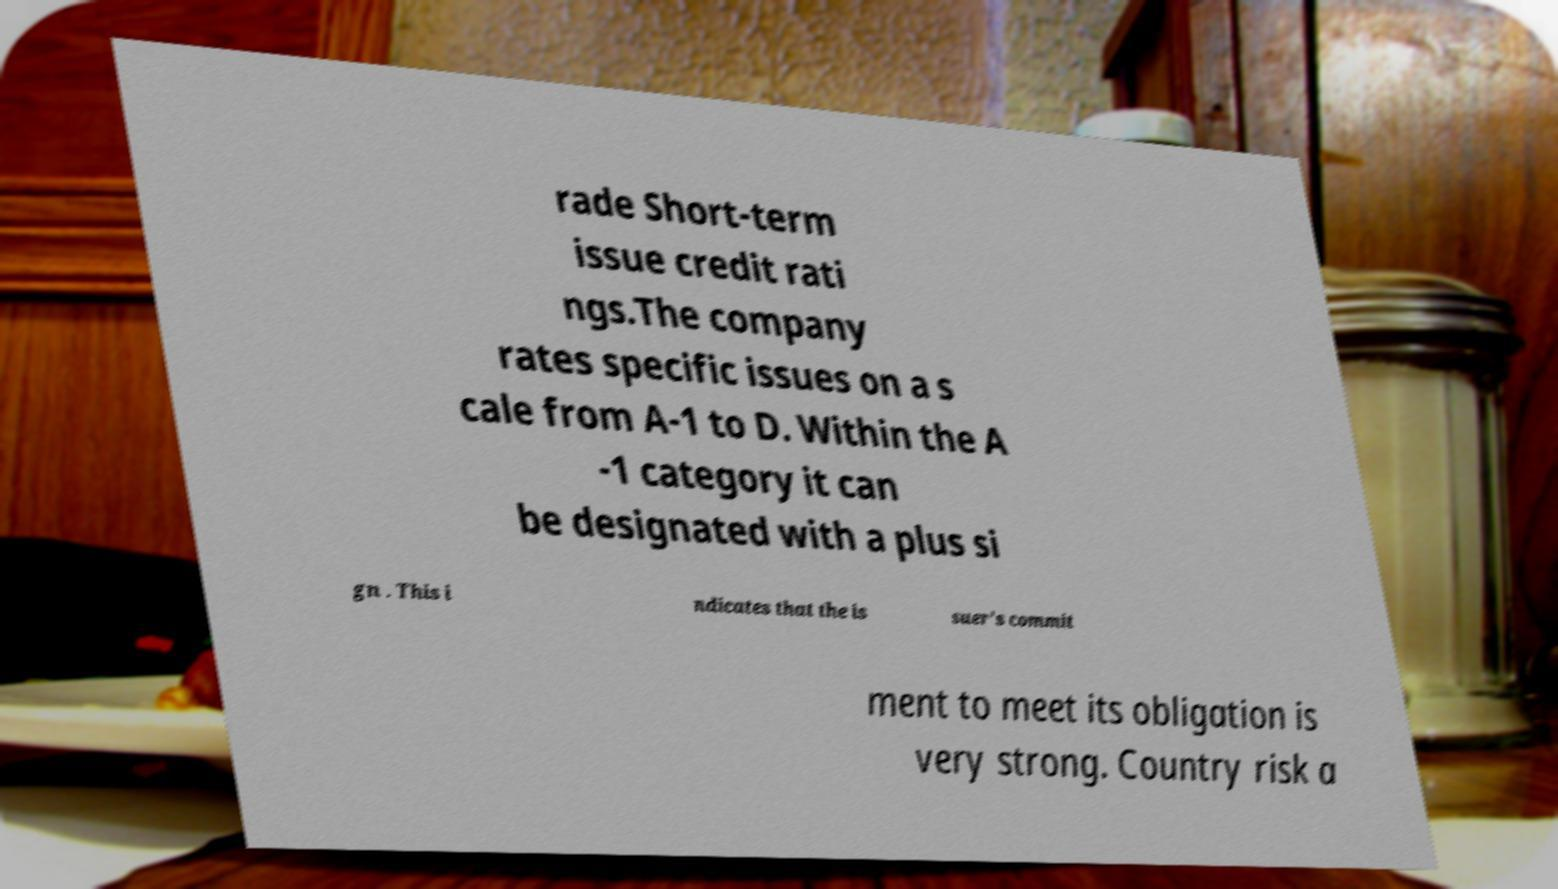Please read and relay the text visible in this image. What does it say? rade Short-term issue credit rati ngs.The company rates specific issues on a s cale from A-1 to D. Within the A -1 category it can be designated with a plus si gn . This i ndicates that the is suer's commit ment to meet its obligation is very strong. Country risk a 